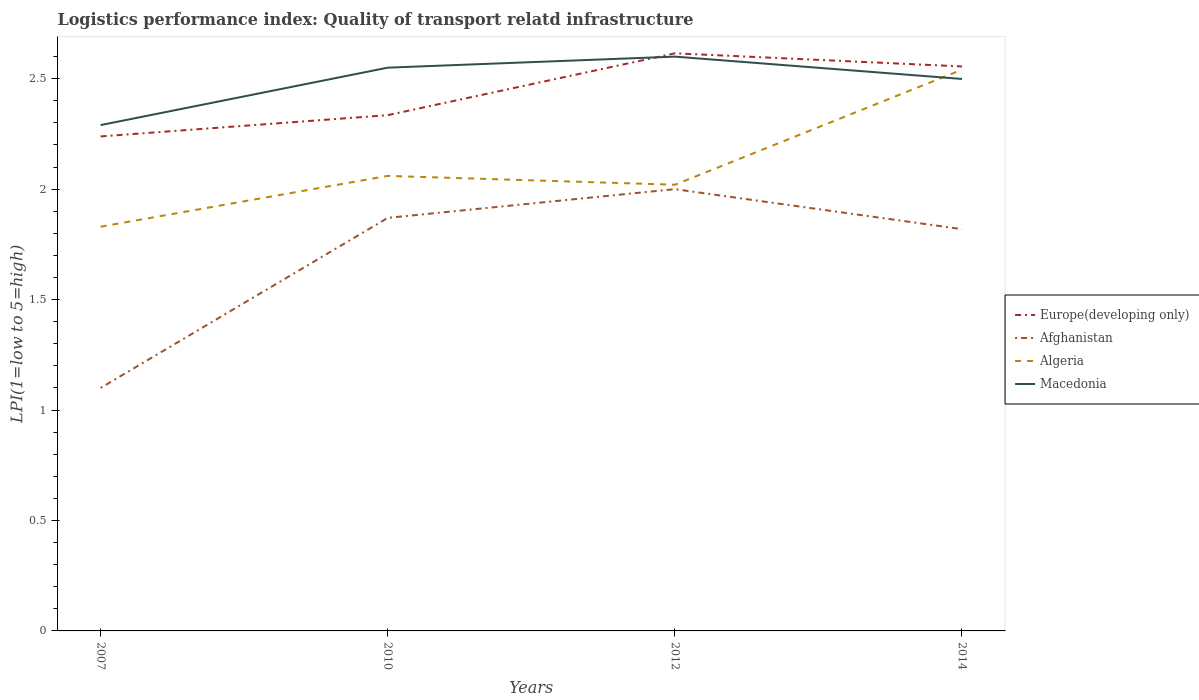Across all years, what is the maximum logistics performance index in Macedonia?
Offer a very short reply. 2.29. In which year was the logistics performance index in Macedonia maximum?
Make the answer very short. 2007. What is the total logistics performance index in Algeria in the graph?
Give a very brief answer. -0.23. What is the difference between the highest and the second highest logistics performance index in Algeria?
Offer a terse response. 0.71. Is the logistics performance index in Afghanistan strictly greater than the logistics performance index in Macedonia over the years?
Your answer should be compact. Yes. How many lines are there?
Your answer should be very brief. 4. How many years are there in the graph?
Ensure brevity in your answer.  4. What is the difference between two consecutive major ticks on the Y-axis?
Keep it short and to the point. 0.5. Are the values on the major ticks of Y-axis written in scientific E-notation?
Keep it short and to the point. No. Does the graph contain any zero values?
Ensure brevity in your answer.  No. How many legend labels are there?
Ensure brevity in your answer.  4. How are the legend labels stacked?
Ensure brevity in your answer.  Vertical. What is the title of the graph?
Your response must be concise. Logistics performance index: Quality of transport relatd infrastructure. What is the label or title of the X-axis?
Provide a succinct answer. Years. What is the label or title of the Y-axis?
Your answer should be compact. LPI(1=low to 5=high). What is the LPI(1=low to 5=high) in Europe(developing only) in 2007?
Make the answer very short. 2.24. What is the LPI(1=low to 5=high) of Algeria in 2007?
Provide a short and direct response. 1.83. What is the LPI(1=low to 5=high) of Macedonia in 2007?
Your answer should be compact. 2.29. What is the LPI(1=low to 5=high) of Europe(developing only) in 2010?
Offer a very short reply. 2.33. What is the LPI(1=low to 5=high) in Afghanistan in 2010?
Provide a short and direct response. 1.87. What is the LPI(1=low to 5=high) of Algeria in 2010?
Ensure brevity in your answer.  2.06. What is the LPI(1=low to 5=high) in Macedonia in 2010?
Offer a terse response. 2.55. What is the LPI(1=low to 5=high) of Europe(developing only) in 2012?
Keep it short and to the point. 2.62. What is the LPI(1=low to 5=high) of Algeria in 2012?
Provide a short and direct response. 2.02. What is the LPI(1=low to 5=high) in Macedonia in 2012?
Your response must be concise. 2.6. What is the LPI(1=low to 5=high) in Europe(developing only) in 2014?
Your answer should be very brief. 2.56. What is the LPI(1=low to 5=high) in Afghanistan in 2014?
Offer a very short reply. 1.82. What is the LPI(1=low to 5=high) in Algeria in 2014?
Your answer should be compact. 2.54. What is the LPI(1=low to 5=high) in Macedonia in 2014?
Ensure brevity in your answer.  2.5. Across all years, what is the maximum LPI(1=low to 5=high) in Europe(developing only)?
Make the answer very short. 2.62. Across all years, what is the maximum LPI(1=low to 5=high) in Algeria?
Your answer should be compact. 2.54. Across all years, what is the maximum LPI(1=low to 5=high) in Macedonia?
Your answer should be compact. 2.6. Across all years, what is the minimum LPI(1=low to 5=high) in Europe(developing only)?
Provide a succinct answer. 2.24. Across all years, what is the minimum LPI(1=low to 5=high) in Algeria?
Offer a very short reply. 1.83. Across all years, what is the minimum LPI(1=low to 5=high) in Macedonia?
Your response must be concise. 2.29. What is the total LPI(1=low to 5=high) in Europe(developing only) in the graph?
Offer a terse response. 9.74. What is the total LPI(1=low to 5=high) of Afghanistan in the graph?
Offer a terse response. 6.79. What is the total LPI(1=low to 5=high) of Algeria in the graph?
Give a very brief answer. 8.45. What is the total LPI(1=low to 5=high) in Macedonia in the graph?
Provide a short and direct response. 9.94. What is the difference between the LPI(1=low to 5=high) of Europe(developing only) in 2007 and that in 2010?
Ensure brevity in your answer.  -0.1. What is the difference between the LPI(1=low to 5=high) of Afghanistan in 2007 and that in 2010?
Provide a short and direct response. -0.77. What is the difference between the LPI(1=low to 5=high) in Algeria in 2007 and that in 2010?
Offer a very short reply. -0.23. What is the difference between the LPI(1=low to 5=high) in Macedonia in 2007 and that in 2010?
Your response must be concise. -0.26. What is the difference between the LPI(1=low to 5=high) in Europe(developing only) in 2007 and that in 2012?
Provide a succinct answer. -0.38. What is the difference between the LPI(1=low to 5=high) of Algeria in 2007 and that in 2012?
Provide a short and direct response. -0.19. What is the difference between the LPI(1=low to 5=high) of Macedonia in 2007 and that in 2012?
Give a very brief answer. -0.31. What is the difference between the LPI(1=low to 5=high) of Europe(developing only) in 2007 and that in 2014?
Offer a terse response. -0.32. What is the difference between the LPI(1=low to 5=high) in Afghanistan in 2007 and that in 2014?
Your answer should be compact. -0.72. What is the difference between the LPI(1=low to 5=high) of Algeria in 2007 and that in 2014?
Your answer should be compact. -0.71. What is the difference between the LPI(1=low to 5=high) in Macedonia in 2007 and that in 2014?
Your response must be concise. -0.21. What is the difference between the LPI(1=low to 5=high) in Europe(developing only) in 2010 and that in 2012?
Ensure brevity in your answer.  -0.28. What is the difference between the LPI(1=low to 5=high) of Afghanistan in 2010 and that in 2012?
Provide a short and direct response. -0.13. What is the difference between the LPI(1=low to 5=high) of Algeria in 2010 and that in 2012?
Ensure brevity in your answer.  0.04. What is the difference between the LPI(1=low to 5=high) of Macedonia in 2010 and that in 2012?
Provide a succinct answer. -0.05. What is the difference between the LPI(1=low to 5=high) of Europe(developing only) in 2010 and that in 2014?
Ensure brevity in your answer.  -0.22. What is the difference between the LPI(1=low to 5=high) in Afghanistan in 2010 and that in 2014?
Keep it short and to the point. 0.05. What is the difference between the LPI(1=low to 5=high) in Algeria in 2010 and that in 2014?
Provide a succinct answer. -0.48. What is the difference between the LPI(1=low to 5=high) in Macedonia in 2010 and that in 2014?
Ensure brevity in your answer.  0.05. What is the difference between the LPI(1=low to 5=high) of Europe(developing only) in 2012 and that in 2014?
Give a very brief answer. 0.06. What is the difference between the LPI(1=low to 5=high) in Afghanistan in 2012 and that in 2014?
Keep it short and to the point. 0.18. What is the difference between the LPI(1=low to 5=high) of Algeria in 2012 and that in 2014?
Keep it short and to the point. -0.52. What is the difference between the LPI(1=low to 5=high) of Macedonia in 2012 and that in 2014?
Offer a terse response. 0.1. What is the difference between the LPI(1=low to 5=high) in Europe(developing only) in 2007 and the LPI(1=low to 5=high) in Afghanistan in 2010?
Offer a very short reply. 0.37. What is the difference between the LPI(1=low to 5=high) of Europe(developing only) in 2007 and the LPI(1=low to 5=high) of Algeria in 2010?
Your answer should be very brief. 0.18. What is the difference between the LPI(1=low to 5=high) in Europe(developing only) in 2007 and the LPI(1=low to 5=high) in Macedonia in 2010?
Provide a short and direct response. -0.31. What is the difference between the LPI(1=low to 5=high) of Afghanistan in 2007 and the LPI(1=low to 5=high) of Algeria in 2010?
Your response must be concise. -0.96. What is the difference between the LPI(1=low to 5=high) of Afghanistan in 2007 and the LPI(1=low to 5=high) of Macedonia in 2010?
Offer a terse response. -1.45. What is the difference between the LPI(1=low to 5=high) in Algeria in 2007 and the LPI(1=low to 5=high) in Macedonia in 2010?
Keep it short and to the point. -0.72. What is the difference between the LPI(1=low to 5=high) of Europe(developing only) in 2007 and the LPI(1=low to 5=high) of Afghanistan in 2012?
Offer a terse response. 0.24. What is the difference between the LPI(1=low to 5=high) of Europe(developing only) in 2007 and the LPI(1=low to 5=high) of Algeria in 2012?
Ensure brevity in your answer.  0.22. What is the difference between the LPI(1=low to 5=high) in Europe(developing only) in 2007 and the LPI(1=low to 5=high) in Macedonia in 2012?
Give a very brief answer. -0.36. What is the difference between the LPI(1=low to 5=high) in Afghanistan in 2007 and the LPI(1=low to 5=high) in Algeria in 2012?
Ensure brevity in your answer.  -0.92. What is the difference between the LPI(1=low to 5=high) of Algeria in 2007 and the LPI(1=low to 5=high) of Macedonia in 2012?
Offer a terse response. -0.77. What is the difference between the LPI(1=low to 5=high) of Europe(developing only) in 2007 and the LPI(1=low to 5=high) of Afghanistan in 2014?
Keep it short and to the point. 0.42. What is the difference between the LPI(1=low to 5=high) of Europe(developing only) in 2007 and the LPI(1=low to 5=high) of Algeria in 2014?
Your answer should be very brief. -0.3. What is the difference between the LPI(1=low to 5=high) of Europe(developing only) in 2007 and the LPI(1=low to 5=high) of Macedonia in 2014?
Your response must be concise. -0.26. What is the difference between the LPI(1=low to 5=high) of Afghanistan in 2007 and the LPI(1=low to 5=high) of Algeria in 2014?
Your response must be concise. -1.44. What is the difference between the LPI(1=low to 5=high) of Afghanistan in 2007 and the LPI(1=low to 5=high) of Macedonia in 2014?
Ensure brevity in your answer.  -1.4. What is the difference between the LPI(1=low to 5=high) in Algeria in 2007 and the LPI(1=low to 5=high) in Macedonia in 2014?
Offer a very short reply. -0.67. What is the difference between the LPI(1=low to 5=high) in Europe(developing only) in 2010 and the LPI(1=low to 5=high) in Afghanistan in 2012?
Offer a terse response. 0.34. What is the difference between the LPI(1=low to 5=high) of Europe(developing only) in 2010 and the LPI(1=low to 5=high) of Algeria in 2012?
Your answer should be compact. 0.32. What is the difference between the LPI(1=low to 5=high) of Europe(developing only) in 2010 and the LPI(1=low to 5=high) of Macedonia in 2012?
Give a very brief answer. -0.27. What is the difference between the LPI(1=low to 5=high) in Afghanistan in 2010 and the LPI(1=low to 5=high) in Macedonia in 2012?
Provide a short and direct response. -0.73. What is the difference between the LPI(1=low to 5=high) in Algeria in 2010 and the LPI(1=low to 5=high) in Macedonia in 2012?
Your answer should be compact. -0.54. What is the difference between the LPI(1=low to 5=high) in Europe(developing only) in 2010 and the LPI(1=low to 5=high) in Afghanistan in 2014?
Provide a succinct answer. 0.52. What is the difference between the LPI(1=low to 5=high) in Europe(developing only) in 2010 and the LPI(1=low to 5=high) in Algeria in 2014?
Your answer should be very brief. -0.21. What is the difference between the LPI(1=low to 5=high) of Europe(developing only) in 2010 and the LPI(1=low to 5=high) of Macedonia in 2014?
Your answer should be compact. -0.16. What is the difference between the LPI(1=low to 5=high) of Afghanistan in 2010 and the LPI(1=low to 5=high) of Algeria in 2014?
Make the answer very short. -0.67. What is the difference between the LPI(1=low to 5=high) of Afghanistan in 2010 and the LPI(1=low to 5=high) of Macedonia in 2014?
Provide a succinct answer. -0.63. What is the difference between the LPI(1=low to 5=high) in Algeria in 2010 and the LPI(1=low to 5=high) in Macedonia in 2014?
Offer a very short reply. -0.44. What is the difference between the LPI(1=low to 5=high) of Europe(developing only) in 2012 and the LPI(1=low to 5=high) of Afghanistan in 2014?
Provide a short and direct response. 0.8. What is the difference between the LPI(1=low to 5=high) in Europe(developing only) in 2012 and the LPI(1=low to 5=high) in Algeria in 2014?
Provide a succinct answer. 0.07. What is the difference between the LPI(1=low to 5=high) in Europe(developing only) in 2012 and the LPI(1=low to 5=high) in Macedonia in 2014?
Provide a short and direct response. 0.12. What is the difference between the LPI(1=low to 5=high) in Afghanistan in 2012 and the LPI(1=low to 5=high) in Algeria in 2014?
Keep it short and to the point. -0.54. What is the difference between the LPI(1=low to 5=high) in Afghanistan in 2012 and the LPI(1=low to 5=high) in Macedonia in 2014?
Offer a very short reply. -0.5. What is the difference between the LPI(1=low to 5=high) of Algeria in 2012 and the LPI(1=low to 5=high) of Macedonia in 2014?
Keep it short and to the point. -0.48. What is the average LPI(1=low to 5=high) in Europe(developing only) per year?
Offer a very short reply. 2.44. What is the average LPI(1=low to 5=high) of Afghanistan per year?
Give a very brief answer. 1.7. What is the average LPI(1=low to 5=high) in Algeria per year?
Keep it short and to the point. 2.11. What is the average LPI(1=low to 5=high) of Macedonia per year?
Keep it short and to the point. 2.48. In the year 2007, what is the difference between the LPI(1=low to 5=high) in Europe(developing only) and LPI(1=low to 5=high) in Afghanistan?
Provide a short and direct response. 1.14. In the year 2007, what is the difference between the LPI(1=low to 5=high) of Europe(developing only) and LPI(1=low to 5=high) of Algeria?
Ensure brevity in your answer.  0.41. In the year 2007, what is the difference between the LPI(1=low to 5=high) in Europe(developing only) and LPI(1=low to 5=high) in Macedonia?
Your answer should be compact. -0.05. In the year 2007, what is the difference between the LPI(1=low to 5=high) in Afghanistan and LPI(1=low to 5=high) in Algeria?
Give a very brief answer. -0.73. In the year 2007, what is the difference between the LPI(1=low to 5=high) of Afghanistan and LPI(1=low to 5=high) of Macedonia?
Your answer should be compact. -1.19. In the year 2007, what is the difference between the LPI(1=low to 5=high) of Algeria and LPI(1=low to 5=high) of Macedonia?
Offer a very short reply. -0.46. In the year 2010, what is the difference between the LPI(1=low to 5=high) of Europe(developing only) and LPI(1=low to 5=high) of Afghanistan?
Keep it short and to the point. 0.47. In the year 2010, what is the difference between the LPI(1=low to 5=high) of Europe(developing only) and LPI(1=low to 5=high) of Algeria?
Provide a succinct answer. 0.28. In the year 2010, what is the difference between the LPI(1=low to 5=high) in Europe(developing only) and LPI(1=low to 5=high) in Macedonia?
Give a very brief answer. -0.21. In the year 2010, what is the difference between the LPI(1=low to 5=high) in Afghanistan and LPI(1=low to 5=high) in Algeria?
Make the answer very short. -0.19. In the year 2010, what is the difference between the LPI(1=low to 5=high) in Afghanistan and LPI(1=low to 5=high) in Macedonia?
Provide a succinct answer. -0.68. In the year 2010, what is the difference between the LPI(1=low to 5=high) of Algeria and LPI(1=low to 5=high) of Macedonia?
Give a very brief answer. -0.49. In the year 2012, what is the difference between the LPI(1=low to 5=high) in Europe(developing only) and LPI(1=low to 5=high) in Afghanistan?
Offer a terse response. 0.61. In the year 2012, what is the difference between the LPI(1=low to 5=high) in Europe(developing only) and LPI(1=low to 5=high) in Algeria?
Make the answer very short. 0.59. In the year 2012, what is the difference between the LPI(1=low to 5=high) of Europe(developing only) and LPI(1=low to 5=high) of Macedonia?
Make the answer very short. 0.01. In the year 2012, what is the difference between the LPI(1=low to 5=high) in Afghanistan and LPI(1=low to 5=high) in Algeria?
Provide a succinct answer. -0.02. In the year 2012, what is the difference between the LPI(1=low to 5=high) in Algeria and LPI(1=low to 5=high) in Macedonia?
Offer a very short reply. -0.58. In the year 2014, what is the difference between the LPI(1=low to 5=high) in Europe(developing only) and LPI(1=low to 5=high) in Afghanistan?
Provide a succinct answer. 0.74. In the year 2014, what is the difference between the LPI(1=low to 5=high) of Europe(developing only) and LPI(1=low to 5=high) of Algeria?
Offer a very short reply. 0.01. In the year 2014, what is the difference between the LPI(1=low to 5=high) in Europe(developing only) and LPI(1=low to 5=high) in Macedonia?
Provide a short and direct response. 0.06. In the year 2014, what is the difference between the LPI(1=low to 5=high) in Afghanistan and LPI(1=low to 5=high) in Algeria?
Ensure brevity in your answer.  -0.72. In the year 2014, what is the difference between the LPI(1=low to 5=high) of Afghanistan and LPI(1=low to 5=high) of Macedonia?
Make the answer very short. -0.68. In the year 2014, what is the difference between the LPI(1=low to 5=high) in Algeria and LPI(1=low to 5=high) in Macedonia?
Offer a very short reply. 0.04. What is the ratio of the LPI(1=low to 5=high) of Europe(developing only) in 2007 to that in 2010?
Your answer should be compact. 0.96. What is the ratio of the LPI(1=low to 5=high) in Afghanistan in 2007 to that in 2010?
Make the answer very short. 0.59. What is the ratio of the LPI(1=low to 5=high) in Algeria in 2007 to that in 2010?
Your answer should be very brief. 0.89. What is the ratio of the LPI(1=low to 5=high) in Macedonia in 2007 to that in 2010?
Offer a terse response. 0.9. What is the ratio of the LPI(1=low to 5=high) of Europe(developing only) in 2007 to that in 2012?
Provide a short and direct response. 0.86. What is the ratio of the LPI(1=low to 5=high) of Afghanistan in 2007 to that in 2012?
Your answer should be compact. 0.55. What is the ratio of the LPI(1=low to 5=high) in Algeria in 2007 to that in 2012?
Provide a succinct answer. 0.91. What is the ratio of the LPI(1=low to 5=high) of Macedonia in 2007 to that in 2012?
Make the answer very short. 0.88. What is the ratio of the LPI(1=low to 5=high) in Europe(developing only) in 2007 to that in 2014?
Give a very brief answer. 0.88. What is the ratio of the LPI(1=low to 5=high) in Afghanistan in 2007 to that in 2014?
Offer a terse response. 0.6. What is the ratio of the LPI(1=low to 5=high) of Algeria in 2007 to that in 2014?
Your answer should be very brief. 0.72. What is the ratio of the LPI(1=low to 5=high) of Macedonia in 2007 to that in 2014?
Make the answer very short. 0.92. What is the ratio of the LPI(1=low to 5=high) of Europe(developing only) in 2010 to that in 2012?
Offer a terse response. 0.89. What is the ratio of the LPI(1=low to 5=high) in Afghanistan in 2010 to that in 2012?
Provide a short and direct response. 0.94. What is the ratio of the LPI(1=low to 5=high) in Algeria in 2010 to that in 2012?
Your response must be concise. 1.02. What is the ratio of the LPI(1=low to 5=high) of Macedonia in 2010 to that in 2012?
Keep it short and to the point. 0.98. What is the ratio of the LPI(1=low to 5=high) of Europe(developing only) in 2010 to that in 2014?
Ensure brevity in your answer.  0.91. What is the ratio of the LPI(1=low to 5=high) in Afghanistan in 2010 to that in 2014?
Give a very brief answer. 1.03. What is the ratio of the LPI(1=low to 5=high) in Algeria in 2010 to that in 2014?
Your response must be concise. 0.81. What is the ratio of the LPI(1=low to 5=high) of Macedonia in 2010 to that in 2014?
Offer a terse response. 1.02. What is the ratio of the LPI(1=low to 5=high) in Europe(developing only) in 2012 to that in 2014?
Keep it short and to the point. 1.02. What is the ratio of the LPI(1=low to 5=high) in Afghanistan in 2012 to that in 2014?
Your response must be concise. 1.1. What is the ratio of the LPI(1=low to 5=high) of Algeria in 2012 to that in 2014?
Offer a very short reply. 0.8. What is the ratio of the LPI(1=low to 5=high) in Macedonia in 2012 to that in 2014?
Ensure brevity in your answer.  1.04. What is the difference between the highest and the second highest LPI(1=low to 5=high) in Europe(developing only)?
Provide a succinct answer. 0.06. What is the difference between the highest and the second highest LPI(1=low to 5=high) of Afghanistan?
Give a very brief answer. 0.13. What is the difference between the highest and the second highest LPI(1=low to 5=high) in Algeria?
Your answer should be very brief. 0.48. What is the difference between the highest and the lowest LPI(1=low to 5=high) of Europe(developing only)?
Provide a short and direct response. 0.38. What is the difference between the highest and the lowest LPI(1=low to 5=high) of Algeria?
Give a very brief answer. 0.71. What is the difference between the highest and the lowest LPI(1=low to 5=high) of Macedonia?
Provide a short and direct response. 0.31. 